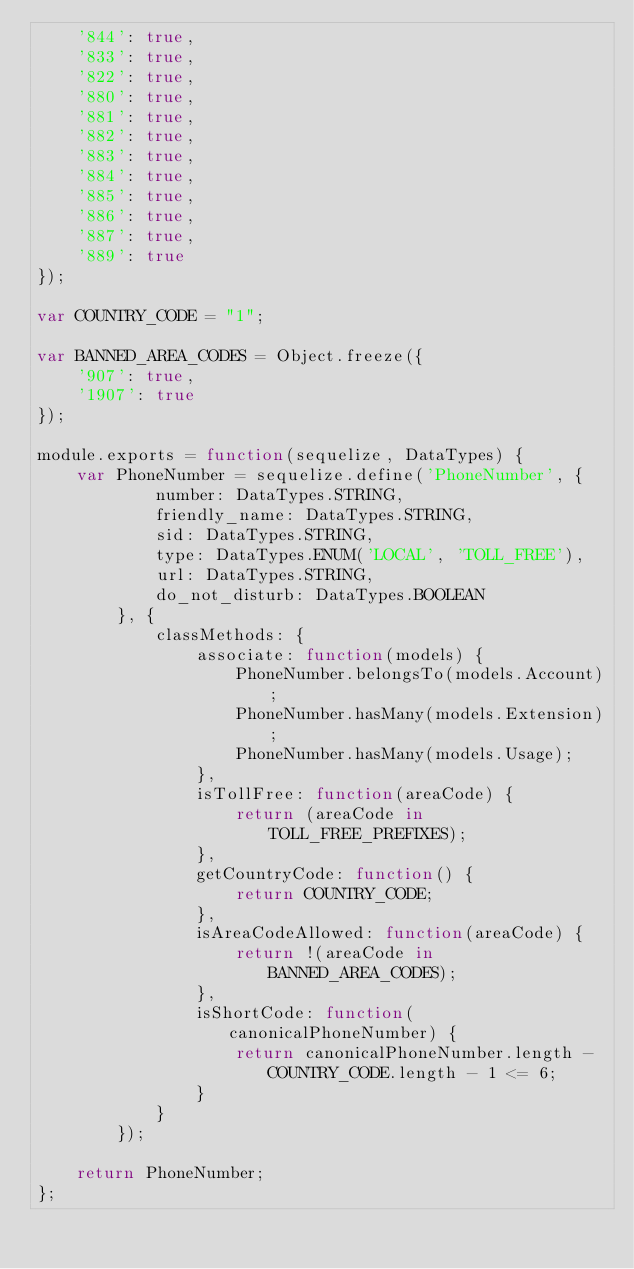<code> <loc_0><loc_0><loc_500><loc_500><_JavaScript_>    '844': true,
    '833': true,
    '822': true,
    '880': true,
    '881': true,
    '882': true,
    '883': true,
    '884': true,
    '885': true,
    '886': true,
    '887': true,
    '889': true
});

var COUNTRY_CODE = "1";

var BANNED_AREA_CODES = Object.freeze({
    '907': true,
    '1907': true
});

module.exports = function(sequelize, DataTypes) {
    var PhoneNumber = sequelize.define('PhoneNumber', {
            number: DataTypes.STRING,
            friendly_name: DataTypes.STRING,
            sid: DataTypes.STRING,
            type: DataTypes.ENUM('LOCAL', 'TOLL_FREE'),
            url: DataTypes.STRING,
            do_not_disturb: DataTypes.BOOLEAN
        }, {
            classMethods: {
                associate: function(models) {
                    PhoneNumber.belongsTo(models.Account);
                    PhoneNumber.hasMany(models.Extension);
                    PhoneNumber.hasMany(models.Usage);
                },
                isTollFree: function(areaCode) {
                    return (areaCode in TOLL_FREE_PREFIXES);
                },
                getCountryCode: function() {
                    return COUNTRY_CODE;
                },
                isAreaCodeAllowed: function(areaCode) {
                    return !(areaCode in BANNED_AREA_CODES);
                },
                isShortCode: function(canonicalPhoneNumber) {
                    return canonicalPhoneNumber.length - COUNTRY_CODE.length - 1 <= 6;
                }
            }
        });

    return PhoneNumber;
};
</code> 